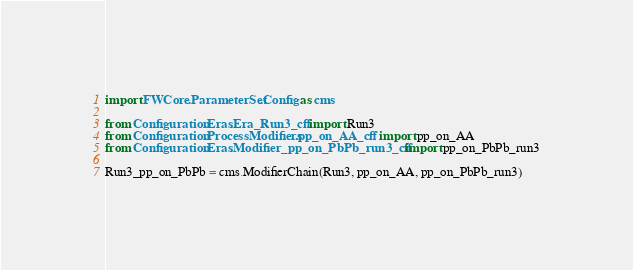Convert code to text. <code><loc_0><loc_0><loc_500><loc_500><_Python_>import FWCore.ParameterSet.Config as cms

from Configuration.Eras.Era_Run3_cff import Run3
from Configuration.ProcessModifiers.pp_on_AA_cff import pp_on_AA
from Configuration.Eras.Modifier_pp_on_PbPb_run3_cff import pp_on_PbPb_run3

Run3_pp_on_PbPb = cms.ModifierChain(Run3, pp_on_AA, pp_on_PbPb_run3)
</code> 